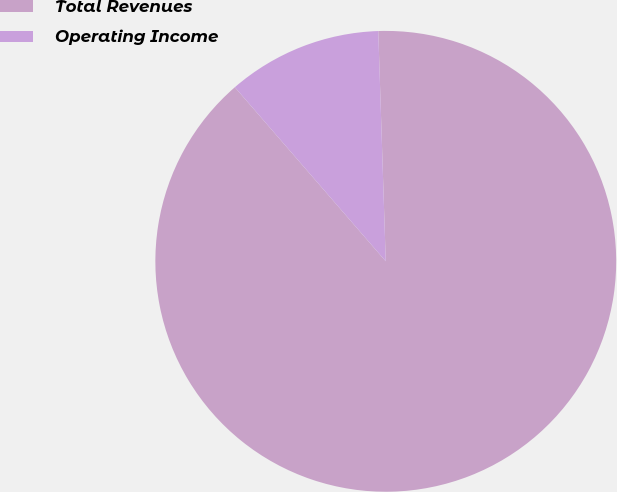Convert chart. <chart><loc_0><loc_0><loc_500><loc_500><pie_chart><fcel>Total Revenues<fcel>Operating Income<nl><fcel>89.15%<fcel>10.85%<nl></chart> 